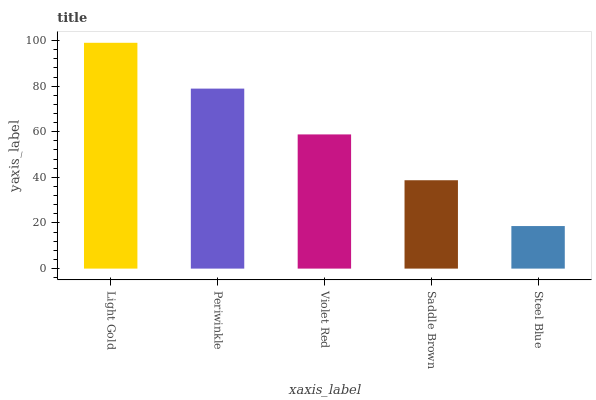Is Steel Blue the minimum?
Answer yes or no. Yes. Is Light Gold the maximum?
Answer yes or no. Yes. Is Periwinkle the minimum?
Answer yes or no. No. Is Periwinkle the maximum?
Answer yes or no. No. Is Light Gold greater than Periwinkle?
Answer yes or no. Yes. Is Periwinkle less than Light Gold?
Answer yes or no. Yes. Is Periwinkle greater than Light Gold?
Answer yes or no. No. Is Light Gold less than Periwinkle?
Answer yes or no. No. Is Violet Red the high median?
Answer yes or no. Yes. Is Violet Red the low median?
Answer yes or no. Yes. Is Saddle Brown the high median?
Answer yes or no. No. Is Light Gold the low median?
Answer yes or no. No. 